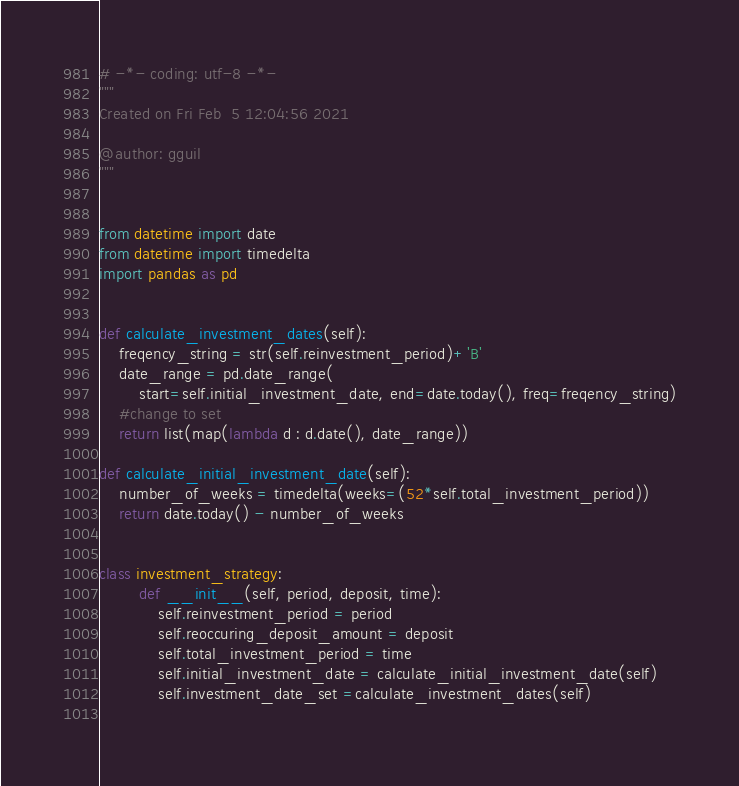Convert code to text. <code><loc_0><loc_0><loc_500><loc_500><_Python_># -*- coding: utf-8 -*-
"""
Created on Fri Feb  5 12:04:56 2021

@author: gguil
"""


from datetime import date
from datetime import timedelta
import pandas as pd


def calculate_investment_dates(self):
    freqency_string = str(self.reinvestment_period)+'B'
    date_range = pd.date_range(
        start=self.initial_investment_date, end=date.today(), freq=freqency_string)
    #change to set
    return list(map(lambda d : d.date(), date_range))
            
def calculate_initial_investment_date(self):
    number_of_weeks = timedelta(weeks=(52*self.total_investment_period))
    return date.today() - number_of_weeks


class investment_strategy:
        def __init__(self, period, deposit, time):
            self.reinvestment_period = period
            self.reoccuring_deposit_amount = deposit
            self.total_investment_period = time
            self.initial_investment_date = calculate_initial_investment_date(self)
            self.investment_date_set =calculate_investment_dates(self)
            


</code> 